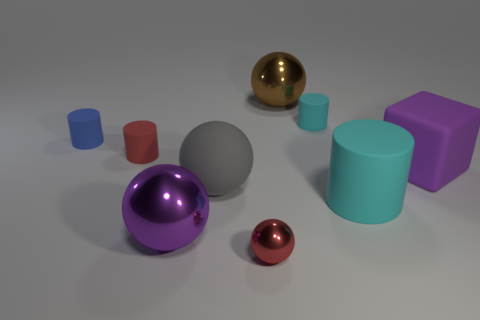Can you describe the lighting and shadows in the scene? The lighting in the image appears to be diffused, with soft shadows cast by the objects pointing to a light source positioned above and to the front-left. This creates a visually pleasing and evenly lit scene with gentle contrast. 